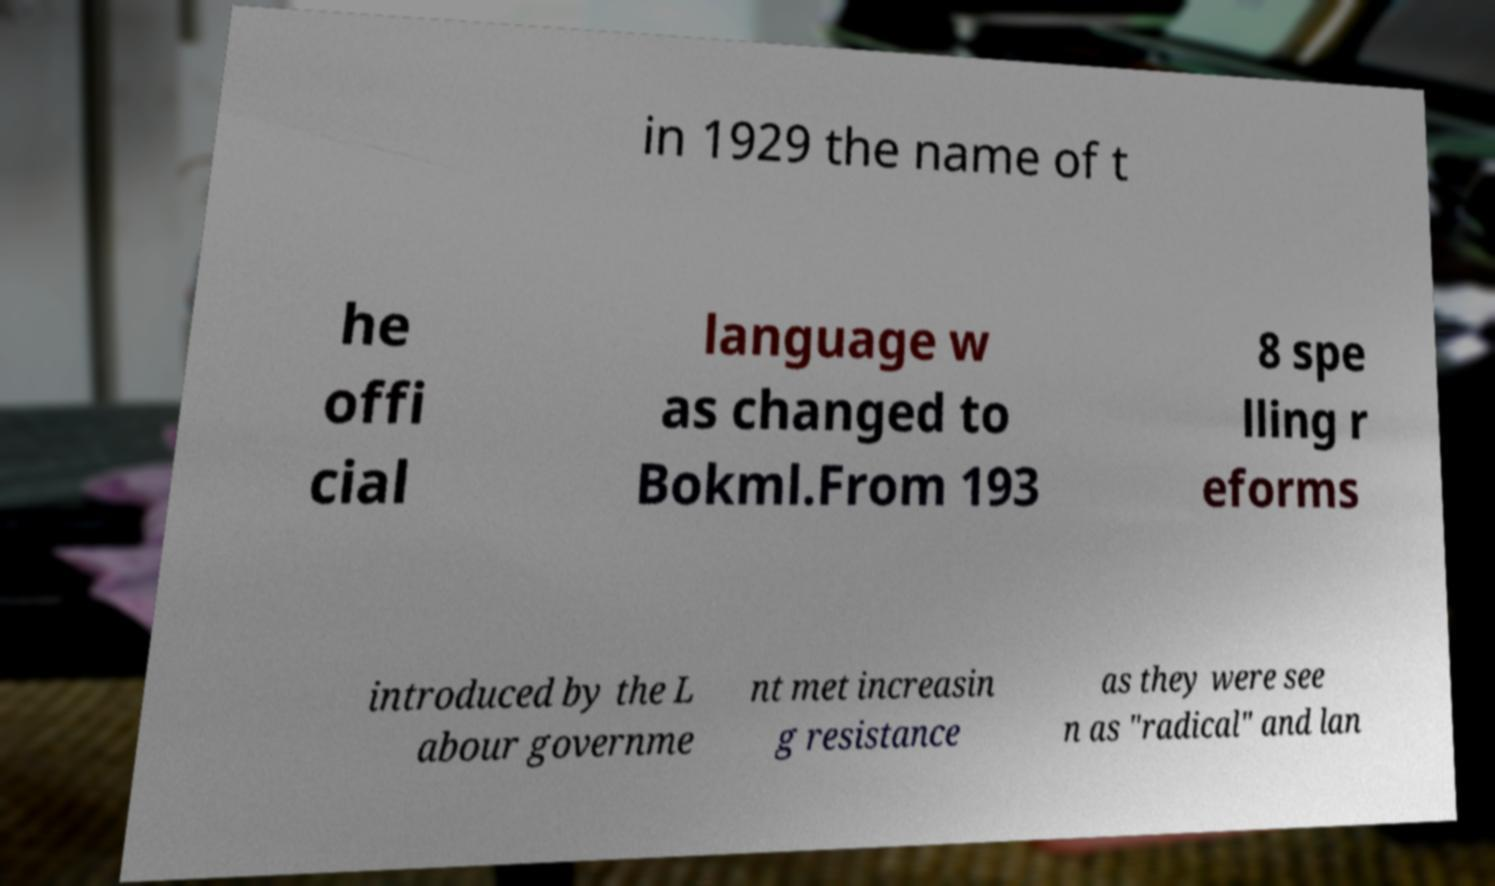Can you accurately transcribe the text from the provided image for me? in 1929 the name of t he offi cial language w as changed to Bokml.From 193 8 spe lling r eforms introduced by the L abour governme nt met increasin g resistance as they were see n as "radical" and lan 